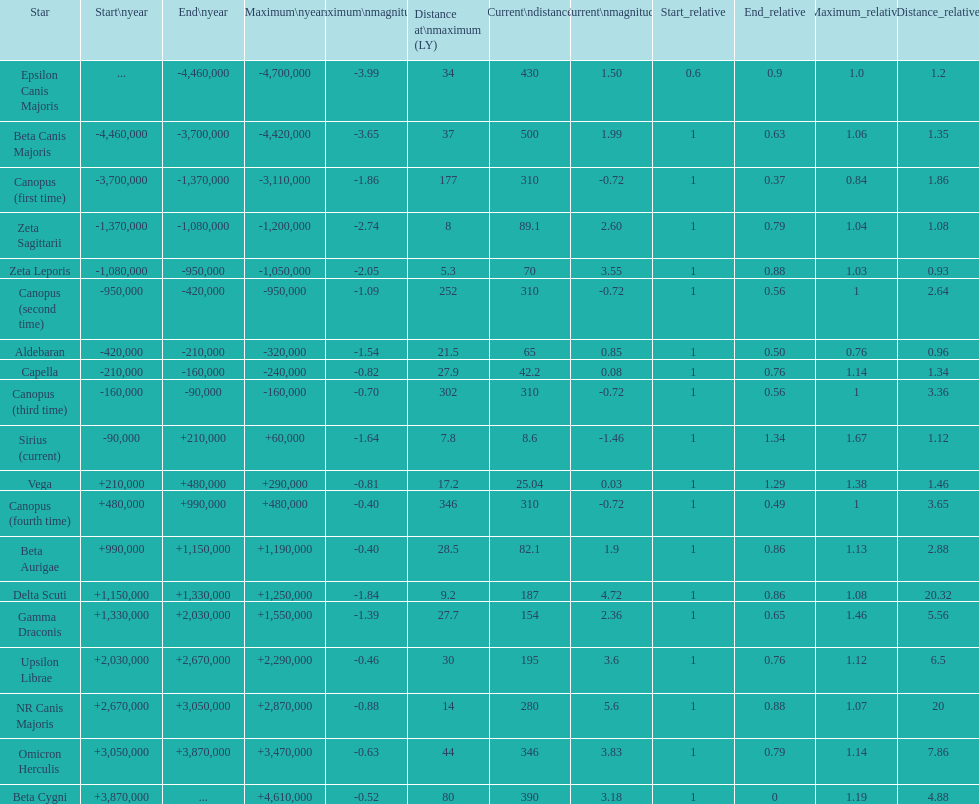How many stars have a current magnitude of at least 1.0? 11. 